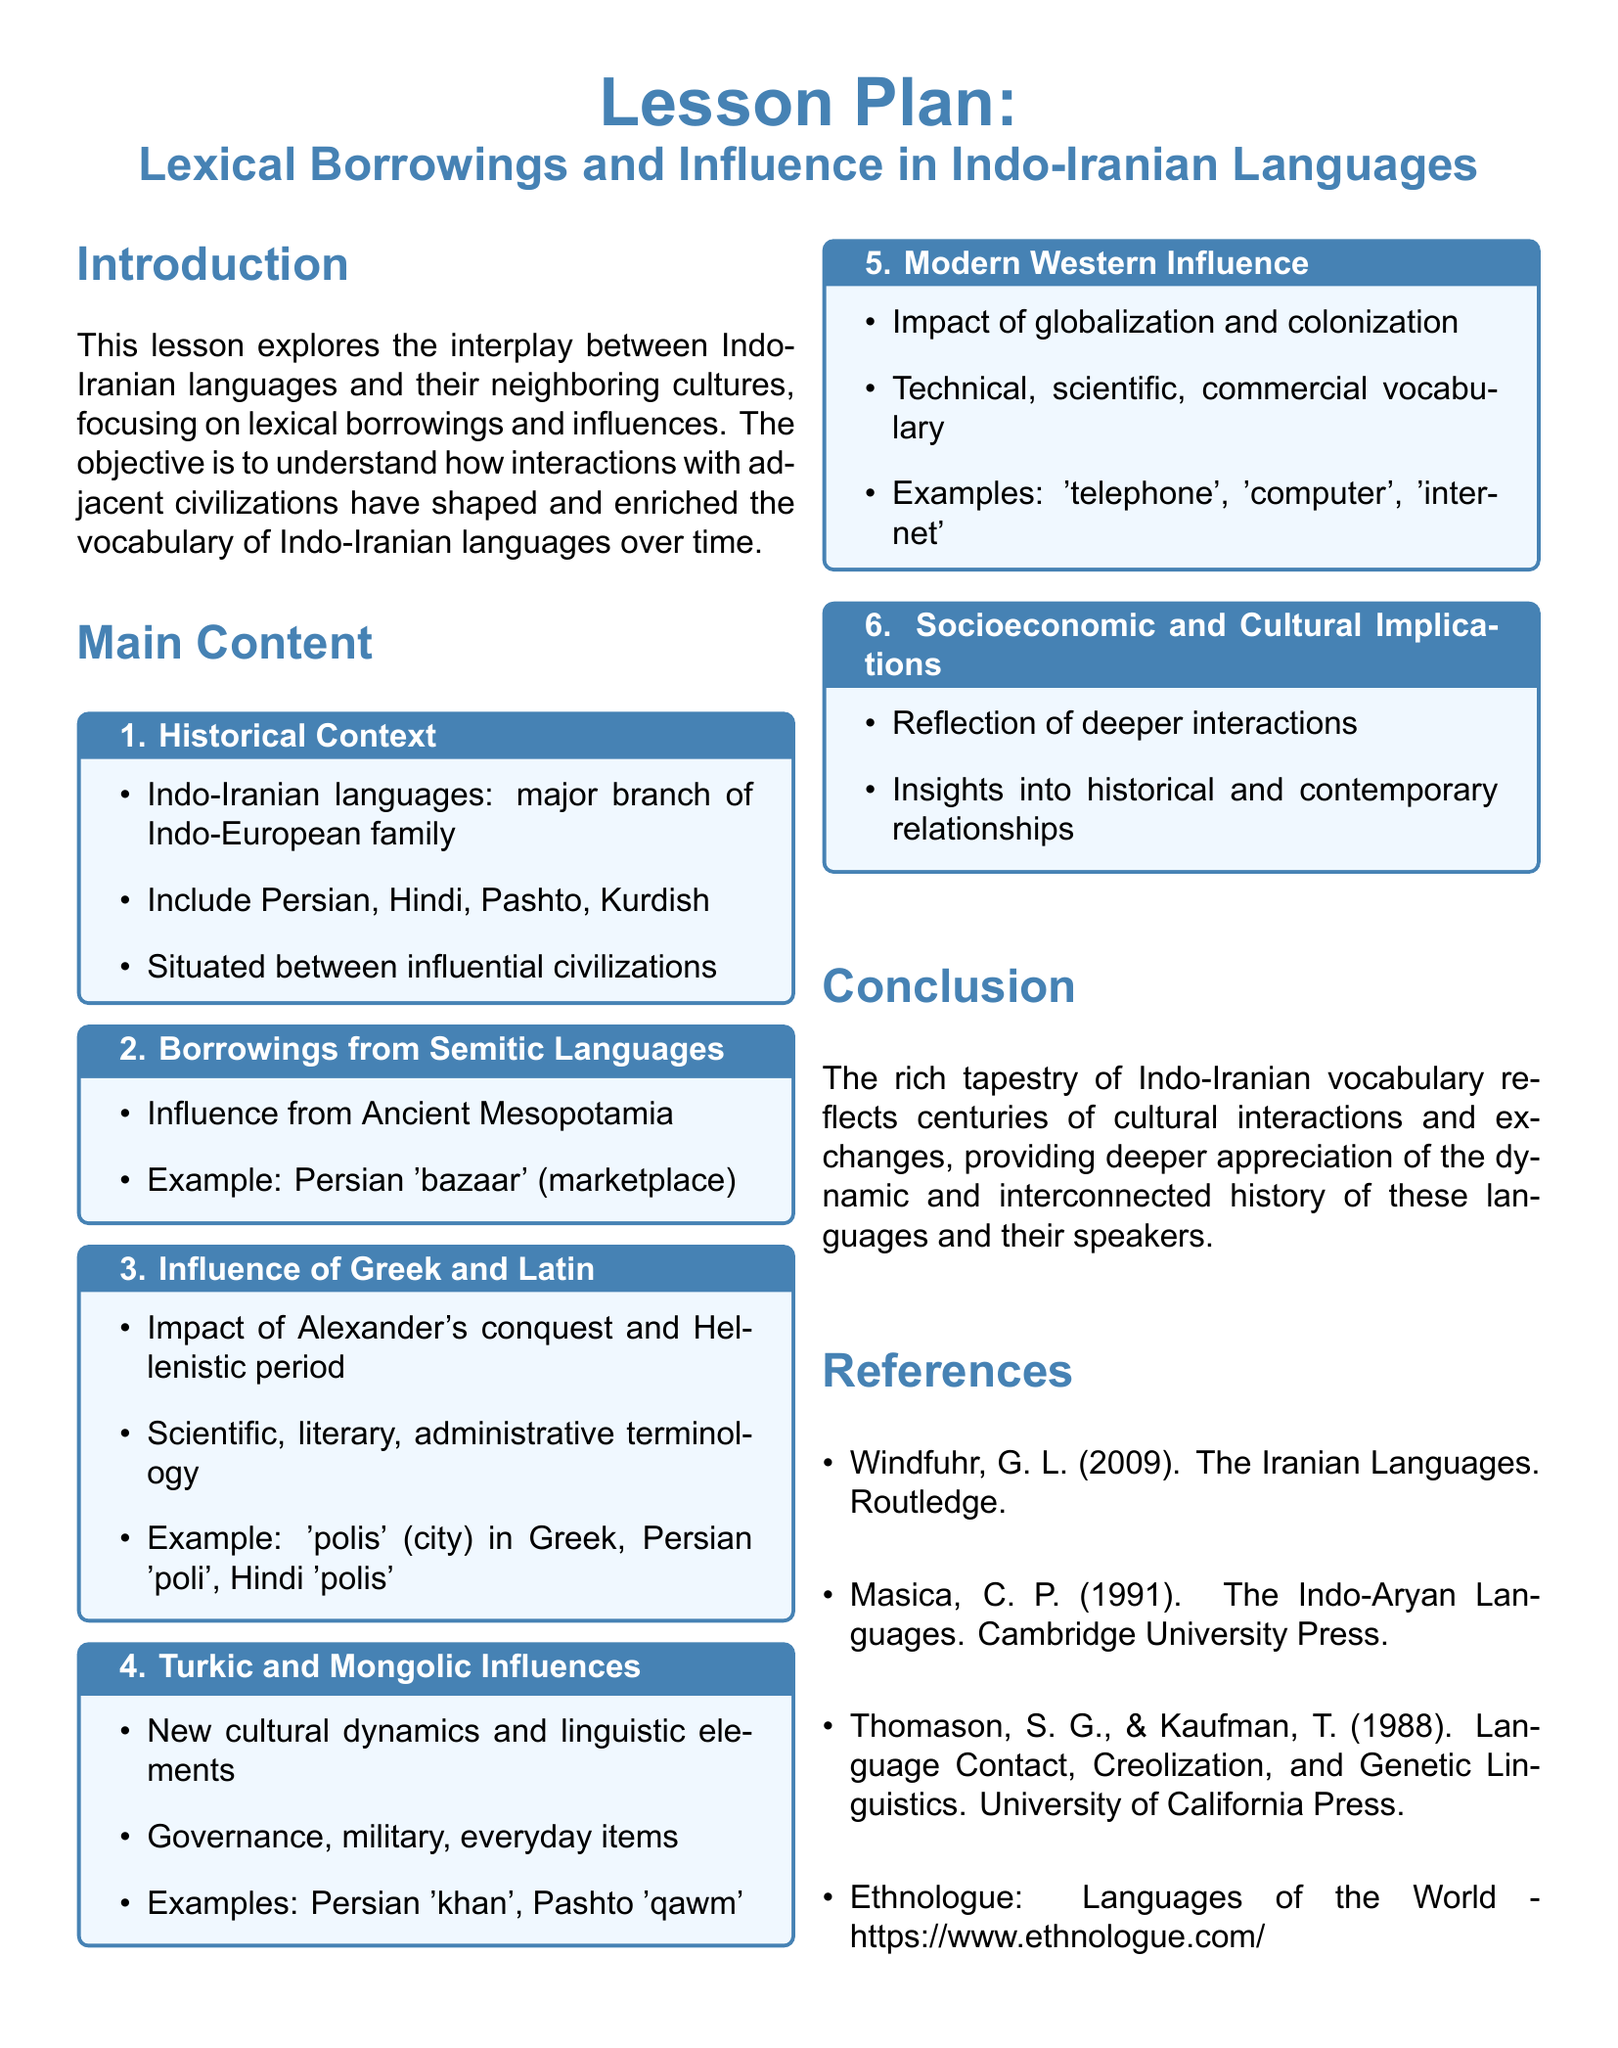what are the major branches of the Indo-European family? The document states that Indo-Iranian languages are a major branch of the Indo-European family.
Answer: Indo-Iranian which influential civilization is mentioned in relation to Semitic languages? The document discusses the influence from Ancient Mesopotamia regarding Semitic languages.
Answer: Ancient Mesopotamia what term is used in Persian for marketplace? The document provides an example of a Persian term that denotes a marketplace.
Answer: bazaar which cultures influenced Indo-Iranian languages during the Hellenistic period? The document refers to the impact of Alexander's conquest and the Hellenistic period on Indo-Iranian vocabulary.
Answer: Greek and Latin what is an example of a modern lexical borrowing in Indo-Iranian languages? The document states that globalization and colonization have led to borrowings in technical and scientific vocabulary.
Answer: telephone what is the significance of lexical borrowings in Indo-Iranian languages? The document explains that lexical borrowings reflect deeper interactions and historical relationships.
Answer: socioeconomic and cultural implications how many main sections are highlighted in the lesson plan? By counting the main content sections, the total number of sections in the lesson is determined.
Answer: 6 who is the author cited in relation to the Iran languages? The document lists an author associated with the Iranian languages.
Answer: Windfuhr, G. L what does the lesson plan conclude about Indo-Iranian vocabulary? The conclusion of the lesson plan reflects on the historical and cultural significance of Indo-Iranian vocabulary.
Answer: cultural interactions and exchanges 